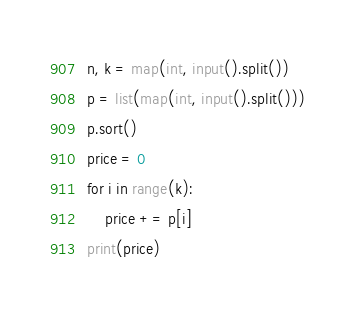<code> <loc_0><loc_0><loc_500><loc_500><_Python_>n, k = map(int, input().split())
p = list(map(int, input().split()))
p.sort()
price = 0
for i in range(k):
    price += p[i]
print(price)</code> 